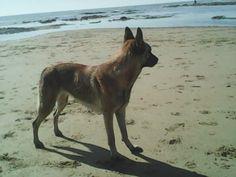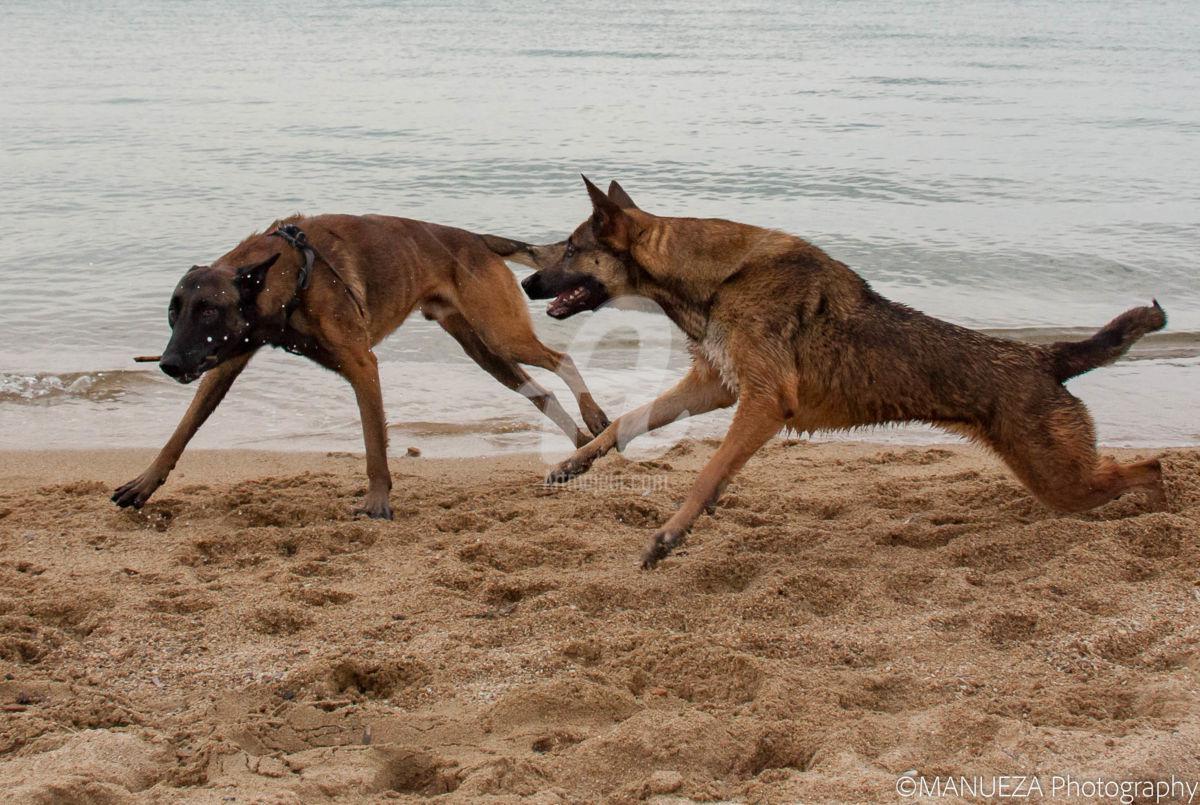The first image is the image on the left, the second image is the image on the right. Given the left and right images, does the statement "A single dog is standing legs and facing right in one of the images." hold true? Answer yes or no. Yes. The first image is the image on the left, the second image is the image on the right. Evaluate the accuracy of this statement regarding the images: "A dog with upright ears is bounding across the sand, and the ocean is visible in at least one image.". Is it true? Answer yes or no. Yes. 